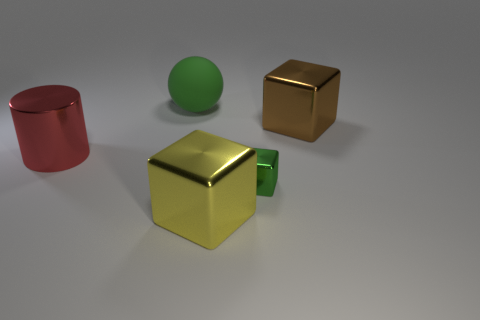What is the shape of the green thing behind the large block that is behind the object on the left side of the ball?
Offer a terse response. Sphere. How many cubes are big yellow objects or big green matte things?
Your answer should be compact. 1. There is a green thing that is in front of the matte object; is there a large cylinder that is in front of it?
Keep it short and to the point. No. Is there any other thing that is the same material as the sphere?
Your answer should be very brief. No. There is a tiny green thing; is it the same shape as the big metal thing behind the big red cylinder?
Offer a very short reply. Yes. How many other things are the same size as the yellow block?
Your answer should be very brief. 3. What number of green things are balls or tiny things?
Your response must be concise. 2. How many big metal things are both on the right side of the big green rubber thing and behind the green block?
Your answer should be compact. 1. What material is the green object that is in front of the large metallic block that is behind the object that is on the left side of the rubber thing?
Give a very brief answer. Metal. What number of other things are the same material as the big red object?
Keep it short and to the point. 3. 